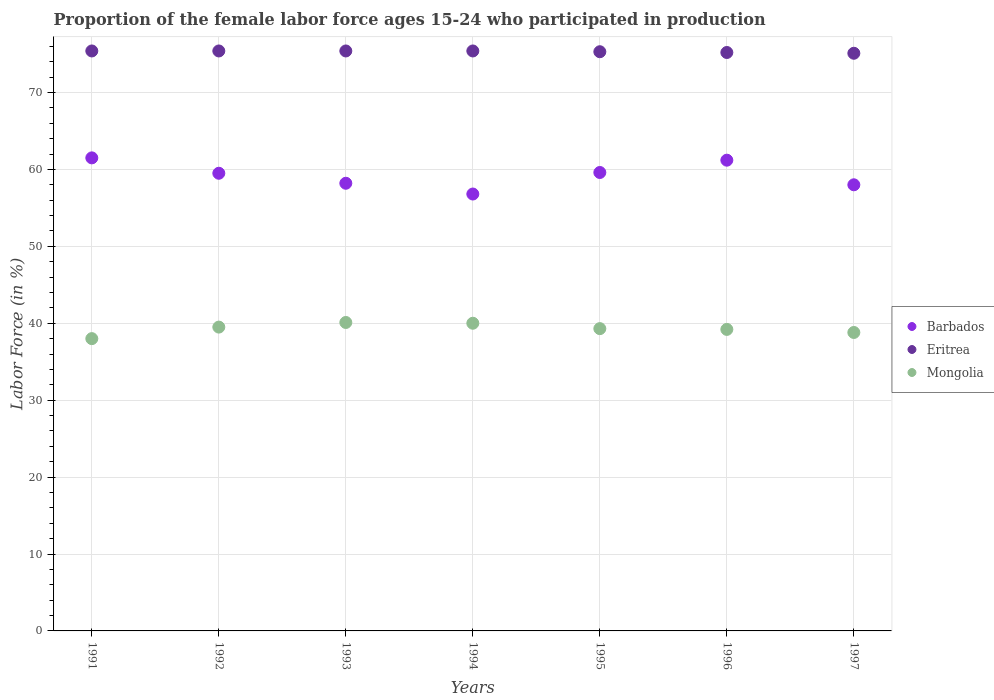What is the proportion of the female labor force who participated in production in Barbados in 1996?
Your answer should be very brief. 61.2. Across all years, what is the maximum proportion of the female labor force who participated in production in Eritrea?
Your answer should be compact. 75.4. Across all years, what is the minimum proportion of the female labor force who participated in production in Mongolia?
Offer a very short reply. 38. What is the total proportion of the female labor force who participated in production in Mongolia in the graph?
Offer a terse response. 274.9. What is the difference between the proportion of the female labor force who participated in production in Eritrea in 1991 and that in 1997?
Provide a succinct answer. 0.3. What is the difference between the proportion of the female labor force who participated in production in Mongolia in 1991 and the proportion of the female labor force who participated in production in Eritrea in 1995?
Offer a very short reply. -37.3. What is the average proportion of the female labor force who participated in production in Barbados per year?
Make the answer very short. 59.26. In the year 1995, what is the difference between the proportion of the female labor force who participated in production in Mongolia and proportion of the female labor force who participated in production in Barbados?
Provide a succinct answer. -20.3. What is the ratio of the proportion of the female labor force who participated in production in Mongolia in 1993 to that in 1996?
Offer a very short reply. 1.02. Is the difference between the proportion of the female labor force who participated in production in Mongolia in 1991 and 1992 greater than the difference between the proportion of the female labor force who participated in production in Barbados in 1991 and 1992?
Your response must be concise. No. What is the difference between the highest and the second highest proportion of the female labor force who participated in production in Mongolia?
Offer a very short reply. 0.1. What is the difference between the highest and the lowest proportion of the female labor force who participated in production in Eritrea?
Ensure brevity in your answer.  0.3. In how many years, is the proportion of the female labor force who participated in production in Barbados greater than the average proportion of the female labor force who participated in production in Barbados taken over all years?
Provide a succinct answer. 4. How many dotlines are there?
Ensure brevity in your answer.  3. How many years are there in the graph?
Ensure brevity in your answer.  7. What is the difference between two consecutive major ticks on the Y-axis?
Ensure brevity in your answer.  10. Are the values on the major ticks of Y-axis written in scientific E-notation?
Ensure brevity in your answer.  No. Does the graph contain grids?
Provide a short and direct response. Yes. What is the title of the graph?
Provide a succinct answer. Proportion of the female labor force ages 15-24 who participated in production. Does "Puerto Rico" appear as one of the legend labels in the graph?
Provide a succinct answer. No. What is the label or title of the X-axis?
Your answer should be compact. Years. What is the label or title of the Y-axis?
Provide a succinct answer. Labor Force (in %). What is the Labor Force (in %) in Barbados in 1991?
Your answer should be very brief. 61.5. What is the Labor Force (in %) of Eritrea in 1991?
Ensure brevity in your answer.  75.4. What is the Labor Force (in %) of Mongolia in 1991?
Keep it short and to the point. 38. What is the Labor Force (in %) in Barbados in 1992?
Make the answer very short. 59.5. What is the Labor Force (in %) of Eritrea in 1992?
Provide a succinct answer. 75.4. What is the Labor Force (in %) of Mongolia in 1992?
Your answer should be compact. 39.5. What is the Labor Force (in %) of Barbados in 1993?
Provide a succinct answer. 58.2. What is the Labor Force (in %) in Eritrea in 1993?
Offer a very short reply. 75.4. What is the Labor Force (in %) of Mongolia in 1993?
Ensure brevity in your answer.  40.1. What is the Labor Force (in %) of Barbados in 1994?
Ensure brevity in your answer.  56.8. What is the Labor Force (in %) in Eritrea in 1994?
Give a very brief answer. 75.4. What is the Labor Force (in %) of Mongolia in 1994?
Your response must be concise. 40. What is the Labor Force (in %) of Barbados in 1995?
Your answer should be compact. 59.6. What is the Labor Force (in %) of Eritrea in 1995?
Your answer should be very brief. 75.3. What is the Labor Force (in %) of Mongolia in 1995?
Ensure brevity in your answer.  39.3. What is the Labor Force (in %) in Barbados in 1996?
Your answer should be very brief. 61.2. What is the Labor Force (in %) in Eritrea in 1996?
Provide a short and direct response. 75.2. What is the Labor Force (in %) of Mongolia in 1996?
Your response must be concise. 39.2. What is the Labor Force (in %) of Eritrea in 1997?
Keep it short and to the point. 75.1. What is the Labor Force (in %) in Mongolia in 1997?
Make the answer very short. 38.8. Across all years, what is the maximum Labor Force (in %) in Barbados?
Provide a succinct answer. 61.5. Across all years, what is the maximum Labor Force (in %) in Eritrea?
Your answer should be very brief. 75.4. Across all years, what is the maximum Labor Force (in %) in Mongolia?
Ensure brevity in your answer.  40.1. Across all years, what is the minimum Labor Force (in %) in Barbados?
Provide a succinct answer. 56.8. Across all years, what is the minimum Labor Force (in %) of Eritrea?
Your response must be concise. 75.1. What is the total Labor Force (in %) in Barbados in the graph?
Offer a terse response. 414.8. What is the total Labor Force (in %) of Eritrea in the graph?
Ensure brevity in your answer.  527.2. What is the total Labor Force (in %) in Mongolia in the graph?
Your answer should be very brief. 274.9. What is the difference between the Labor Force (in %) in Mongolia in 1991 and that in 1992?
Your response must be concise. -1.5. What is the difference between the Labor Force (in %) of Eritrea in 1991 and that in 1993?
Provide a succinct answer. 0. What is the difference between the Labor Force (in %) in Mongolia in 1991 and that in 1993?
Offer a terse response. -2.1. What is the difference between the Labor Force (in %) in Eritrea in 1991 and that in 1994?
Provide a short and direct response. 0. What is the difference between the Labor Force (in %) of Eritrea in 1991 and that in 1996?
Provide a succinct answer. 0.2. What is the difference between the Labor Force (in %) of Eritrea in 1991 and that in 1997?
Provide a short and direct response. 0.3. What is the difference between the Labor Force (in %) of Barbados in 1992 and that in 1993?
Make the answer very short. 1.3. What is the difference between the Labor Force (in %) in Eritrea in 1992 and that in 1993?
Keep it short and to the point. 0. What is the difference between the Labor Force (in %) in Eritrea in 1992 and that in 1994?
Offer a terse response. 0. What is the difference between the Labor Force (in %) of Barbados in 1992 and that in 1995?
Offer a very short reply. -0.1. What is the difference between the Labor Force (in %) in Eritrea in 1992 and that in 1995?
Your answer should be compact. 0.1. What is the difference between the Labor Force (in %) in Barbados in 1993 and that in 1994?
Offer a very short reply. 1.4. What is the difference between the Labor Force (in %) of Eritrea in 1993 and that in 1994?
Keep it short and to the point. 0. What is the difference between the Labor Force (in %) in Eritrea in 1993 and that in 1995?
Make the answer very short. 0.1. What is the difference between the Labor Force (in %) of Mongolia in 1993 and that in 1995?
Make the answer very short. 0.8. What is the difference between the Labor Force (in %) in Eritrea in 1993 and that in 1997?
Offer a very short reply. 0.3. What is the difference between the Labor Force (in %) in Mongolia in 1993 and that in 1997?
Offer a terse response. 1.3. What is the difference between the Labor Force (in %) in Mongolia in 1994 and that in 1995?
Make the answer very short. 0.7. What is the difference between the Labor Force (in %) in Eritrea in 1994 and that in 1996?
Ensure brevity in your answer.  0.2. What is the difference between the Labor Force (in %) of Mongolia in 1994 and that in 1996?
Make the answer very short. 0.8. What is the difference between the Labor Force (in %) of Barbados in 1994 and that in 1997?
Make the answer very short. -1.2. What is the difference between the Labor Force (in %) of Eritrea in 1994 and that in 1997?
Offer a terse response. 0.3. What is the difference between the Labor Force (in %) in Mongolia in 1994 and that in 1997?
Your response must be concise. 1.2. What is the difference between the Labor Force (in %) of Barbados in 1995 and that in 1996?
Ensure brevity in your answer.  -1.6. What is the difference between the Labor Force (in %) of Eritrea in 1995 and that in 1996?
Offer a very short reply. 0.1. What is the difference between the Labor Force (in %) of Barbados in 1995 and that in 1997?
Your answer should be compact. 1.6. What is the difference between the Labor Force (in %) of Mongolia in 1995 and that in 1997?
Provide a short and direct response. 0.5. What is the difference between the Labor Force (in %) of Barbados in 1996 and that in 1997?
Provide a succinct answer. 3.2. What is the difference between the Labor Force (in %) of Eritrea in 1996 and that in 1997?
Offer a terse response. 0.1. What is the difference between the Labor Force (in %) in Barbados in 1991 and the Labor Force (in %) in Eritrea in 1992?
Offer a very short reply. -13.9. What is the difference between the Labor Force (in %) of Barbados in 1991 and the Labor Force (in %) of Mongolia in 1992?
Provide a succinct answer. 22. What is the difference between the Labor Force (in %) in Eritrea in 1991 and the Labor Force (in %) in Mongolia in 1992?
Your answer should be compact. 35.9. What is the difference between the Labor Force (in %) in Barbados in 1991 and the Labor Force (in %) in Mongolia in 1993?
Offer a very short reply. 21.4. What is the difference between the Labor Force (in %) of Eritrea in 1991 and the Labor Force (in %) of Mongolia in 1993?
Offer a very short reply. 35.3. What is the difference between the Labor Force (in %) in Barbados in 1991 and the Labor Force (in %) in Mongolia in 1994?
Provide a succinct answer. 21.5. What is the difference between the Labor Force (in %) in Eritrea in 1991 and the Labor Force (in %) in Mongolia in 1994?
Provide a succinct answer. 35.4. What is the difference between the Labor Force (in %) in Barbados in 1991 and the Labor Force (in %) in Eritrea in 1995?
Keep it short and to the point. -13.8. What is the difference between the Labor Force (in %) in Eritrea in 1991 and the Labor Force (in %) in Mongolia in 1995?
Ensure brevity in your answer.  36.1. What is the difference between the Labor Force (in %) in Barbados in 1991 and the Labor Force (in %) in Eritrea in 1996?
Make the answer very short. -13.7. What is the difference between the Labor Force (in %) of Barbados in 1991 and the Labor Force (in %) of Mongolia in 1996?
Provide a succinct answer. 22.3. What is the difference between the Labor Force (in %) in Eritrea in 1991 and the Labor Force (in %) in Mongolia in 1996?
Your answer should be very brief. 36.2. What is the difference between the Labor Force (in %) in Barbados in 1991 and the Labor Force (in %) in Eritrea in 1997?
Keep it short and to the point. -13.6. What is the difference between the Labor Force (in %) in Barbados in 1991 and the Labor Force (in %) in Mongolia in 1997?
Provide a succinct answer. 22.7. What is the difference between the Labor Force (in %) in Eritrea in 1991 and the Labor Force (in %) in Mongolia in 1997?
Provide a short and direct response. 36.6. What is the difference between the Labor Force (in %) in Barbados in 1992 and the Labor Force (in %) in Eritrea in 1993?
Ensure brevity in your answer.  -15.9. What is the difference between the Labor Force (in %) of Eritrea in 1992 and the Labor Force (in %) of Mongolia in 1993?
Provide a short and direct response. 35.3. What is the difference between the Labor Force (in %) of Barbados in 1992 and the Labor Force (in %) of Eritrea in 1994?
Offer a very short reply. -15.9. What is the difference between the Labor Force (in %) in Barbados in 1992 and the Labor Force (in %) in Mongolia in 1994?
Keep it short and to the point. 19.5. What is the difference between the Labor Force (in %) in Eritrea in 1992 and the Labor Force (in %) in Mongolia in 1994?
Keep it short and to the point. 35.4. What is the difference between the Labor Force (in %) in Barbados in 1992 and the Labor Force (in %) in Eritrea in 1995?
Provide a short and direct response. -15.8. What is the difference between the Labor Force (in %) in Barbados in 1992 and the Labor Force (in %) in Mongolia in 1995?
Make the answer very short. 20.2. What is the difference between the Labor Force (in %) of Eritrea in 1992 and the Labor Force (in %) of Mongolia in 1995?
Ensure brevity in your answer.  36.1. What is the difference between the Labor Force (in %) in Barbados in 1992 and the Labor Force (in %) in Eritrea in 1996?
Make the answer very short. -15.7. What is the difference between the Labor Force (in %) of Barbados in 1992 and the Labor Force (in %) of Mongolia in 1996?
Offer a very short reply. 20.3. What is the difference between the Labor Force (in %) of Eritrea in 1992 and the Labor Force (in %) of Mongolia in 1996?
Provide a short and direct response. 36.2. What is the difference between the Labor Force (in %) in Barbados in 1992 and the Labor Force (in %) in Eritrea in 1997?
Your response must be concise. -15.6. What is the difference between the Labor Force (in %) of Barbados in 1992 and the Labor Force (in %) of Mongolia in 1997?
Keep it short and to the point. 20.7. What is the difference between the Labor Force (in %) of Eritrea in 1992 and the Labor Force (in %) of Mongolia in 1997?
Keep it short and to the point. 36.6. What is the difference between the Labor Force (in %) in Barbados in 1993 and the Labor Force (in %) in Eritrea in 1994?
Make the answer very short. -17.2. What is the difference between the Labor Force (in %) in Eritrea in 1993 and the Labor Force (in %) in Mongolia in 1994?
Your answer should be very brief. 35.4. What is the difference between the Labor Force (in %) in Barbados in 1993 and the Labor Force (in %) in Eritrea in 1995?
Offer a terse response. -17.1. What is the difference between the Labor Force (in %) of Eritrea in 1993 and the Labor Force (in %) of Mongolia in 1995?
Offer a very short reply. 36.1. What is the difference between the Labor Force (in %) of Barbados in 1993 and the Labor Force (in %) of Eritrea in 1996?
Keep it short and to the point. -17. What is the difference between the Labor Force (in %) in Barbados in 1993 and the Labor Force (in %) in Mongolia in 1996?
Ensure brevity in your answer.  19. What is the difference between the Labor Force (in %) of Eritrea in 1993 and the Labor Force (in %) of Mongolia in 1996?
Make the answer very short. 36.2. What is the difference between the Labor Force (in %) in Barbados in 1993 and the Labor Force (in %) in Eritrea in 1997?
Offer a terse response. -16.9. What is the difference between the Labor Force (in %) in Barbados in 1993 and the Labor Force (in %) in Mongolia in 1997?
Provide a succinct answer. 19.4. What is the difference between the Labor Force (in %) in Eritrea in 1993 and the Labor Force (in %) in Mongolia in 1997?
Ensure brevity in your answer.  36.6. What is the difference between the Labor Force (in %) of Barbados in 1994 and the Labor Force (in %) of Eritrea in 1995?
Ensure brevity in your answer.  -18.5. What is the difference between the Labor Force (in %) in Eritrea in 1994 and the Labor Force (in %) in Mongolia in 1995?
Provide a short and direct response. 36.1. What is the difference between the Labor Force (in %) in Barbados in 1994 and the Labor Force (in %) in Eritrea in 1996?
Provide a succinct answer. -18.4. What is the difference between the Labor Force (in %) of Barbados in 1994 and the Labor Force (in %) of Mongolia in 1996?
Your answer should be very brief. 17.6. What is the difference between the Labor Force (in %) of Eritrea in 1994 and the Labor Force (in %) of Mongolia in 1996?
Offer a terse response. 36.2. What is the difference between the Labor Force (in %) in Barbados in 1994 and the Labor Force (in %) in Eritrea in 1997?
Your answer should be compact. -18.3. What is the difference between the Labor Force (in %) of Barbados in 1994 and the Labor Force (in %) of Mongolia in 1997?
Make the answer very short. 18. What is the difference between the Labor Force (in %) in Eritrea in 1994 and the Labor Force (in %) in Mongolia in 1997?
Your response must be concise. 36.6. What is the difference between the Labor Force (in %) in Barbados in 1995 and the Labor Force (in %) in Eritrea in 1996?
Keep it short and to the point. -15.6. What is the difference between the Labor Force (in %) of Barbados in 1995 and the Labor Force (in %) of Mongolia in 1996?
Offer a terse response. 20.4. What is the difference between the Labor Force (in %) of Eritrea in 1995 and the Labor Force (in %) of Mongolia in 1996?
Give a very brief answer. 36.1. What is the difference between the Labor Force (in %) of Barbados in 1995 and the Labor Force (in %) of Eritrea in 1997?
Ensure brevity in your answer.  -15.5. What is the difference between the Labor Force (in %) in Barbados in 1995 and the Labor Force (in %) in Mongolia in 1997?
Keep it short and to the point. 20.8. What is the difference between the Labor Force (in %) in Eritrea in 1995 and the Labor Force (in %) in Mongolia in 1997?
Give a very brief answer. 36.5. What is the difference between the Labor Force (in %) of Barbados in 1996 and the Labor Force (in %) of Mongolia in 1997?
Your response must be concise. 22.4. What is the difference between the Labor Force (in %) in Eritrea in 1996 and the Labor Force (in %) in Mongolia in 1997?
Offer a very short reply. 36.4. What is the average Labor Force (in %) of Barbados per year?
Keep it short and to the point. 59.26. What is the average Labor Force (in %) of Eritrea per year?
Give a very brief answer. 75.31. What is the average Labor Force (in %) of Mongolia per year?
Your answer should be very brief. 39.27. In the year 1991, what is the difference between the Labor Force (in %) of Eritrea and Labor Force (in %) of Mongolia?
Your answer should be very brief. 37.4. In the year 1992, what is the difference between the Labor Force (in %) of Barbados and Labor Force (in %) of Eritrea?
Provide a short and direct response. -15.9. In the year 1992, what is the difference between the Labor Force (in %) of Eritrea and Labor Force (in %) of Mongolia?
Offer a very short reply. 35.9. In the year 1993, what is the difference between the Labor Force (in %) of Barbados and Labor Force (in %) of Eritrea?
Ensure brevity in your answer.  -17.2. In the year 1993, what is the difference between the Labor Force (in %) in Barbados and Labor Force (in %) in Mongolia?
Your response must be concise. 18.1. In the year 1993, what is the difference between the Labor Force (in %) of Eritrea and Labor Force (in %) of Mongolia?
Keep it short and to the point. 35.3. In the year 1994, what is the difference between the Labor Force (in %) in Barbados and Labor Force (in %) in Eritrea?
Your response must be concise. -18.6. In the year 1994, what is the difference between the Labor Force (in %) in Eritrea and Labor Force (in %) in Mongolia?
Offer a very short reply. 35.4. In the year 1995, what is the difference between the Labor Force (in %) in Barbados and Labor Force (in %) in Eritrea?
Make the answer very short. -15.7. In the year 1995, what is the difference between the Labor Force (in %) of Barbados and Labor Force (in %) of Mongolia?
Your answer should be compact. 20.3. In the year 1995, what is the difference between the Labor Force (in %) in Eritrea and Labor Force (in %) in Mongolia?
Your answer should be very brief. 36. In the year 1996, what is the difference between the Labor Force (in %) in Barbados and Labor Force (in %) in Eritrea?
Your response must be concise. -14. In the year 1996, what is the difference between the Labor Force (in %) of Barbados and Labor Force (in %) of Mongolia?
Provide a short and direct response. 22. In the year 1997, what is the difference between the Labor Force (in %) in Barbados and Labor Force (in %) in Eritrea?
Offer a very short reply. -17.1. In the year 1997, what is the difference between the Labor Force (in %) in Eritrea and Labor Force (in %) in Mongolia?
Provide a succinct answer. 36.3. What is the ratio of the Labor Force (in %) of Barbados in 1991 to that in 1992?
Keep it short and to the point. 1.03. What is the ratio of the Labor Force (in %) in Barbados in 1991 to that in 1993?
Ensure brevity in your answer.  1.06. What is the ratio of the Labor Force (in %) of Eritrea in 1991 to that in 1993?
Your answer should be very brief. 1. What is the ratio of the Labor Force (in %) of Mongolia in 1991 to that in 1993?
Provide a succinct answer. 0.95. What is the ratio of the Labor Force (in %) of Barbados in 1991 to that in 1994?
Offer a terse response. 1.08. What is the ratio of the Labor Force (in %) of Eritrea in 1991 to that in 1994?
Your response must be concise. 1. What is the ratio of the Labor Force (in %) of Barbados in 1991 to that in 1995?
Keep it short and to the point. 1.03. What is the ratio of the Labor Force (in %) in Mongolia in 1991 to that in 1995?
Your answer should be compact. 0.97. What is the ratio of the Labor Force (in %) in Mongolia in 1991 to that in 1996?
Provide a short and direct response. 0.97. What is the ratio of the Labor Force (in %) in Barbados in 1991 to that in 1997?
Make the answer very short. 1.06. What is the ratio of the Labor Force (in %) of Eritrea in 1991 to that in 1997?
Provide a short and direct response. 1. What is the ratio of the Labor Force (in %) in Mongolia in 1991 to that in 1997?
Give a very brief answer. 0.98. What is the ratio of the Labor Force (in %) of Barbados in 1992 to that in 1993?
Keep it short and to the point. 1.02. What is the ratio of the Labor Force (in %) of Eritrea in 1992 to that in 1993?
Provide a short and direct response. 1. What is the ratio of the Labor Force (in %) of Barbados in 1992 to that in 1994?
Your answer should be very brief. 1.05. What is the ratio of the Labor Force (in %) in Eritrea in 1992 to that in 1994?
Offer a very short reply. 1. What is the ratio of the Labor Force (in %) of Mongolia in 1992 to that in 1994?
Give a very brief answer. 0.99. What is the ratio of the Labor Force (in %) of Barbados in 1992 to that in 1995?
Offer a terse response. 1. What is the ratio of the Labor Force (in %) in Eritrea in 1992 to that in 1995?
Your answer should be very brief. 1. What is the ratio of the Labor Force (in %) of Mongolia in 1992 to that in 1995?
Give a very brief answer. 1.01. What is the ratio of the Labor Force (in %) of Barbados in 1992 to that in 1996?
Give a very brief answer. 0.97. What is the ratio of the Labor Force (in %) of Eritrea in 1992 to that in 1996?
Provide a succinct answer. 1. What is the ratio of the Labor Force (in %) of Mongolia in 1992 to that in 1996?
Keep it short and to the point. 1.01. What is the ratio of the Labor Force (in %) of Barbados in 1992 to that in 1997?
Your answer should be very brief. 1.03. What is the ratio of the Labor Force (in %) in Mongolia in 1992 to that in 1997?
Your answer should be compact. 1.02. What is the ratio of the Labor Force (in %) of Barbados in 1993 to that in 1994?
Offer a terse response. 1.02. What is the ratio of the Labor Force (in %) of Eritrea in 1993 to that in 1994?
Your response must be concise. 1. What is the ratio of the Labor Force (in %) in Barbados in 1993 to that in 1995?
Your answer should be compact. 0.98. What is the ratio of the Labor Force (in %) of Eritrea in 1993 to that in 1995?
Provide a succinct answer. 1. What is the ratio of the Labor Force (in %) in Mongolia in 1993 to that in 1995?
Provide a succinct answer. 1.02. What is the ratio of the Labor Force (in %) of Barbados in 1993 to that in 1996?
Make the answer very short. 0.95. What is the ratio of the Labor Force (in %) in Eritrea in 1993 to that in 1996?
Make the answer very short. 1. What is the ratio of the Labor Force (in %) of Mongolia in 1993 to that in 1996?
Make the answer very short. 1.02. What is the ratio of the Labor Force (in %) in Mongolia in 1993 to that in 1997?
Give a very brief answer. 1.03. What is the ratio of the Labor Force (in %) in Barbados in 1994 to that in 1995?
Offer a terse response. 0.95. What is the ratio of the Labor Force (in %) in Eritrea in 1994 to that in 1995?
Your answer should be compact. 1. What is the ratio of the Labor Force (in %) in Mongolia in 1994 to that in 1995?
Offer a very short reply. 1.02. What is the ratio of the Labor Force (in %) of Barbados in 1994 to that in 1996?
Provide a succinct answer. 0.93. What is the ratio of the Labor Force (in %) in Mongolia in 1994 to that in 1996?
Your answer should be compact. 1.02. What is the ratio of the Labor Force (in %) of Barbados in 1994 to that in 1997?
Give a very brief answer. 0.98. What is the ratio of the Labor Force (in %) in Mongolia in 1994 to that in 1997?
Make the answer very short. 1.03. What is the ratio of the Labor Force (in %) in Barbados in 1995 to that in 1996?
Ensure brevity in your answer.  0.97. What is the ratio of the Labor Force (in %) of Eritrea in 1995 to that in 1996?
Your answer should be very brief. 1. What is the ratio of the Labor Force (in %) in Mongolia in 1995 to that in 1996?
Give a very brief answer. 1. What is the ratio of the Labor Force (in %) in Barbados in 1995 to that in 1997?
Your response must be concise. 1.03. What is the ratio of the Labor Force (in %) of Mongolia in 1995 to that in 1997?
Your answer should be compact. 1.01. What is the ratio of the Labor Force (in %) in Barbados in 1996 to that in 1997?
Your response must be concise. 1.06. What is the ratio of the Labor Force (in %) of Eritrea in 1996 to that in 1997?
Keep it short and to the point. 1. What is the ratio of the Labor Force (in %) of Mongolia in 1996 to that in 1997?
Provide a succinct answer. 1.01. What is the difference between the highest and the second highest Labor Force (in %) in Barbados?
Ensure brevity in your answer.  0.3. What is the difference between the highest and the second highest Labor Force (in %) in Eritrea?
Give a very brief answer. 0. What is the difference between the highest and the lowest Labor Force (in %) in Barbados?
Your response must be concise. 4.7. What is the difference between the highest and the lowest Labor Force (in %) in Eritrea?
Provide a succinct answer. 0.3. What is the difference between the highest and the lowest Labor Force (in %) in Mongolia?
Offer a terse response. 2.1. 